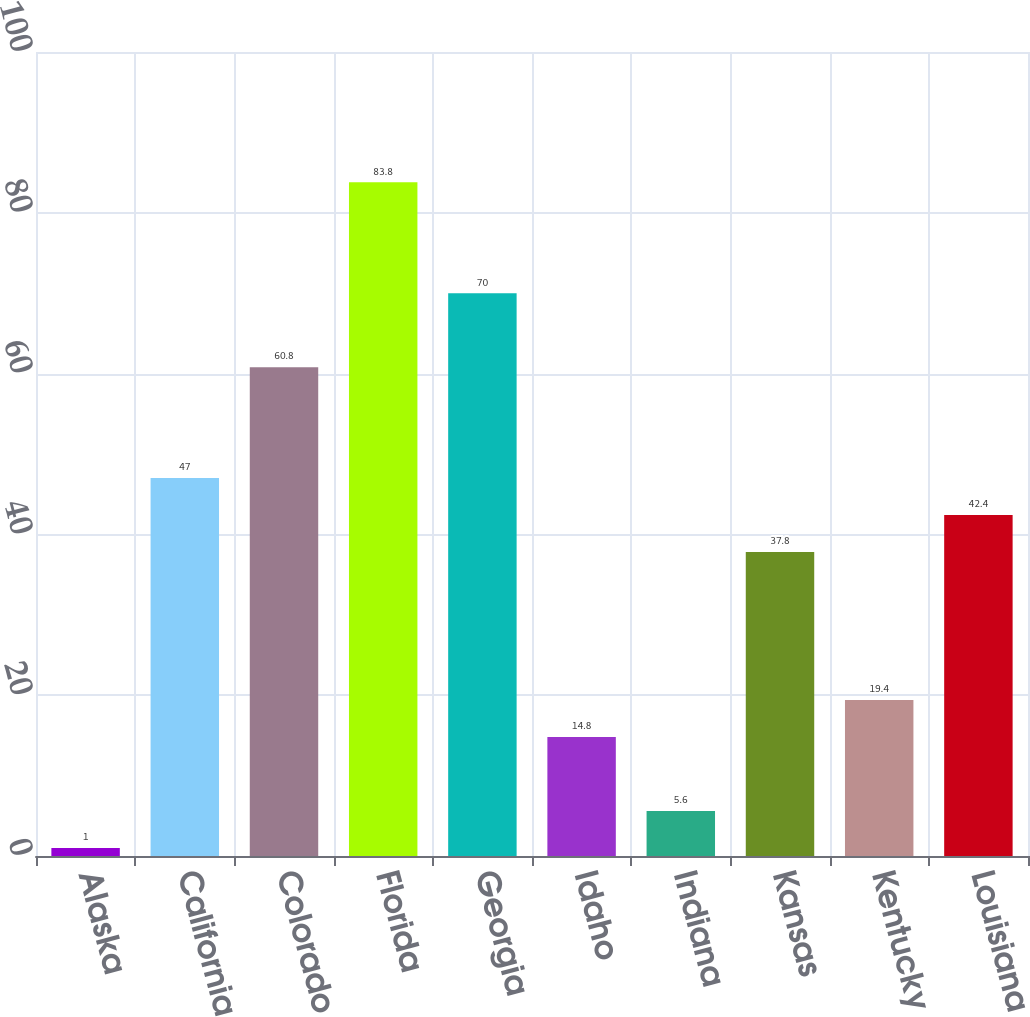<chart> <loc_0><loc_0><loc_500><loc_500><bar_chart><fcel>Alaska<fcel>California<fcel>Colorado<fcel>Florida<fcel>Georgia<fcel>Idaho<fcel>Indiana<fcel>Kansas<fcel>Kentucky<fcel>Louisiana<nl><fcel>1<fcel>47<fcel>60.8<fcel>83.8<fcel>70<fcel>14.8<fcel>5.6<fcel>37.8<fcel>19.4<fcel>42.4<nl></chart> 